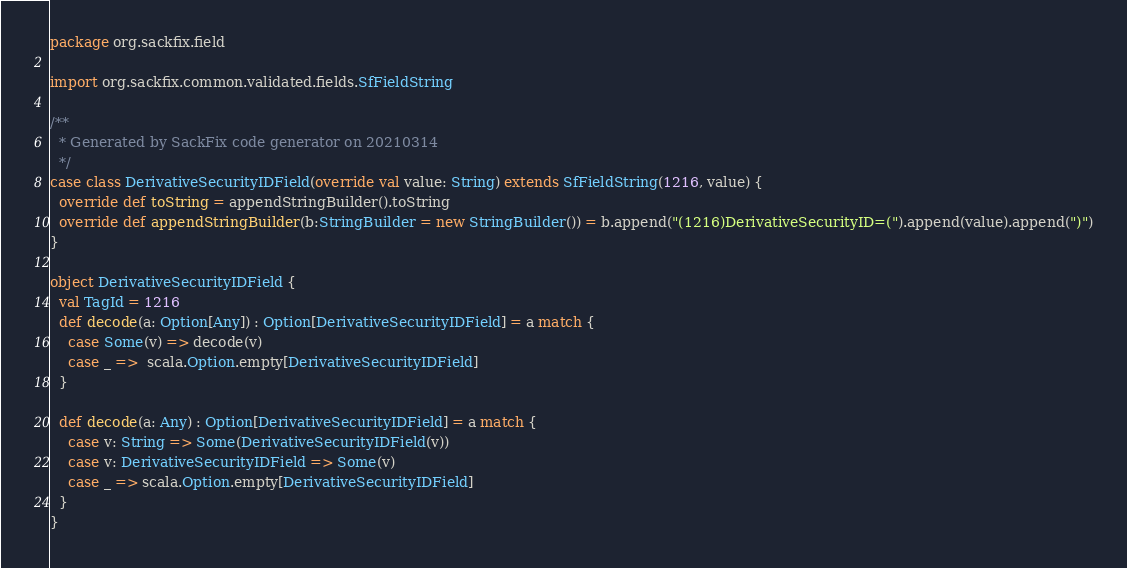Convert code to text. <code><loc_0><loc_0><loc_500><loc_500><_Scala_>package org.sackfix.field

import org.sackfix.common.validated.fields.SfFieldString

/**
  * Generated by SackFix code generator on 20210314
  */
case class DerivativeSecurityIDField(override val value: String) extends SfFieldString(1216, value) {
  override def toString = appendStringBuilder().toString
  override def appendStringBuilder(b:StringBuilder = new StringBuilder()) = b.append("(1216)DerivativeSecurityID=(").append(value).append(")")
}

object DerivativeSecurityIDField {
  val TagId = 1216  
  def decode(a: Option[Any]) : Option[DerivativeSecurityIDField] = a match {
    case Some(v) => decode(v)
    case _ =>  scala.Option.empty[DerivativeSecurityIDField]
  }

  def decode(a: Any) : Option[DerivativeSecurityIDField] = a match {
    case v: String => Some(DerivativeSecurityIDField(v))
    case v: DerivativeSecurityIDField => Some(v)
    case _ => scala.Option.empty[DerivativeSecurityIDField]
  } 
}
</code> 